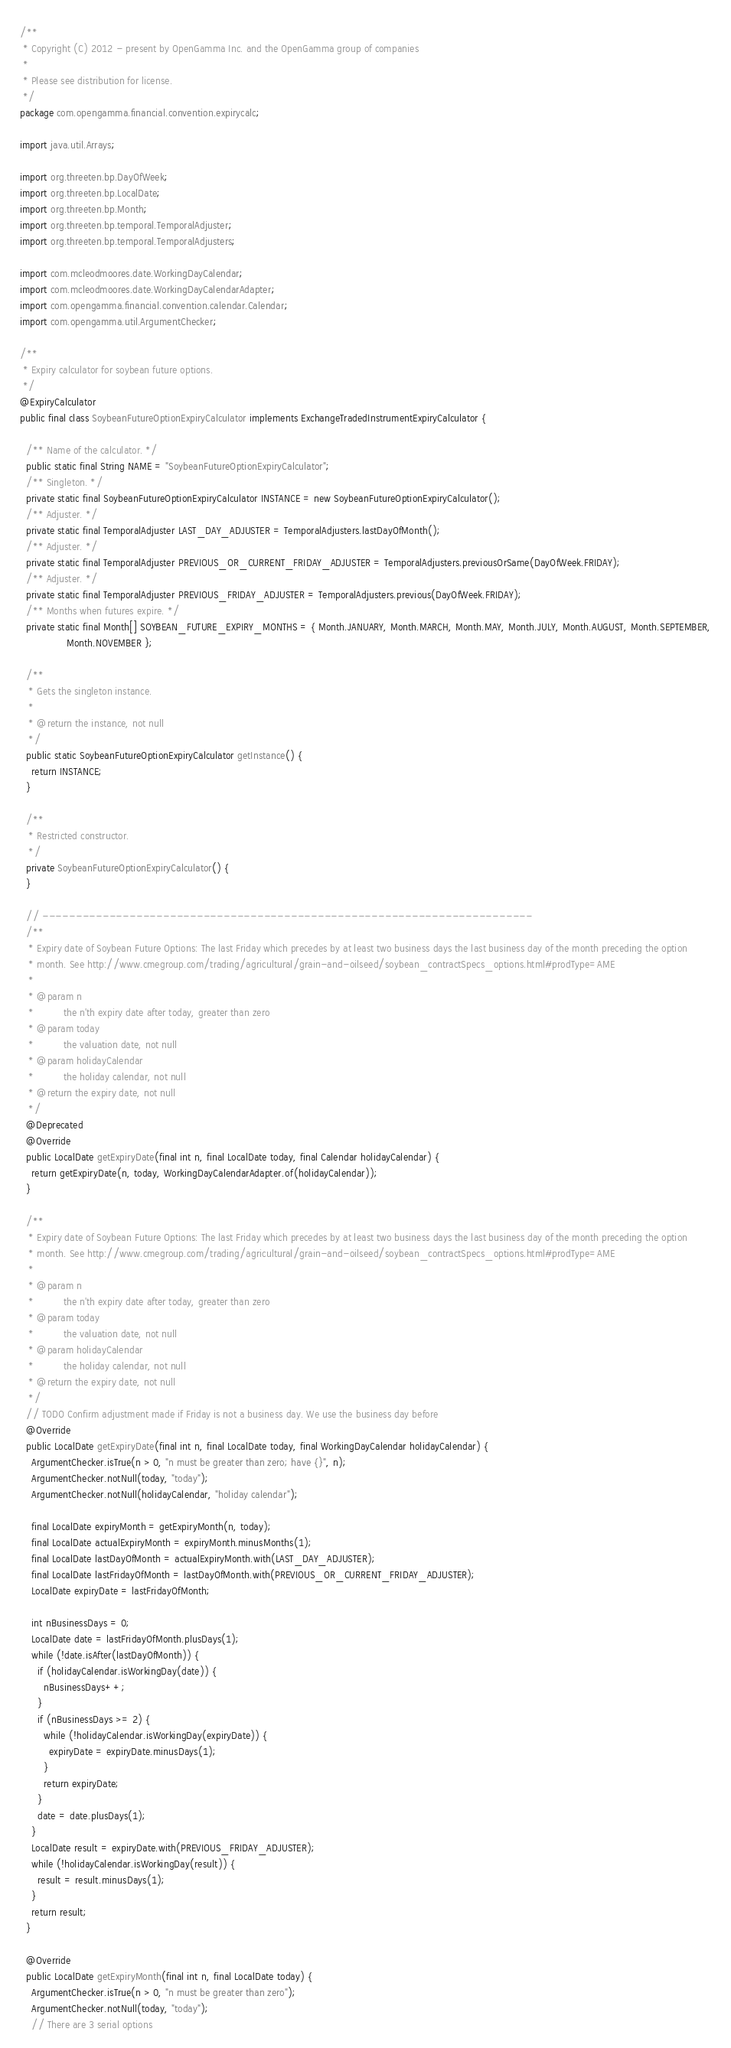<code> <loc_0><loc_0><loc_500><loc_500><_Java_>/**
 * Copyright (C) 2012 - present by OpenGamma Inc. and the OpenGamma group of companies
 *
 * Please see distribution for license.
 */
package com.opengamma.financial.convention.expirycalc;

import java.util.Arrays;

import org.threeten.bp.DayOfWeek;
import org.threeten.bp.LocalDate;
import org.threeten.bp.Month;
import org.threeten.bp.temporal.TemporalAdjuster;
import org.threeten.bp.temporal.TemporalAdjusters;

import com.mcleodmoores.date.WorkingDayCalendar;
import com.mcleodmoores.date.WorkingDayCalendarAdapter;
import com.opengamma.financial.convention.calendar.Calendar;
import com.opengamma.util.ArgumentChecker;

/**
 * Expiry calculator for soybean future options.
 */
@ExpiryCalculator
public final class SoybeanFutureOptionExpiryCalculator implements ExchangeTradedInstrumentExpiryCalculator {

  /** Name of the calculator. */
  public static final String NAME = "SoybeanFutureOptionExpiryCalculator";
  /** Singleton. */
  private static final SoybeanFutureOptionExpiryCalculator INSTANCE = new SoybeanFutureOptionExpiryCalculator();
  /** Adjuster. */
  private static final TemporalAdjuster LAST_DAY_ADJUSTER = TemporalAdjusters.lastDayOfMonth();
  /** Adjuster. */
  private static final TemporalAdjuster PREVIOUS_OR_CURRENT_FRIDAY_ADJUSTER = TemporalAdjusters.previousOrSame(DayOfWeek.FRIDAY);
  /** Adjuster. */
  private static final TemporalAdjuster PREVIOUS_FRIDAY_ADJUSTER = TemporalAdjusters.previous(DayOfWeek.FRIDAY);
  /** Months when futures expire. */
  private static final Month[] SOYBEAN_FUTURE_EXPIRY_MONTHS = { Month.JANUARY, Month.MARCH, Month.MAY, Month.JULY, Month.AUGUST, Month.SEPTEMBER,
                Month.NOVEMBER };

  /**
   * Gets the singleton instance.
   *
   * @return the instance, not null
   */
  public static SoybeanFutureOptionExpiryCalculator getInstance() {
    return INSTANCE;
  }

  /**
   * Restricted constructor.
   */
  private SoybeanFutureOptionExpiryCalculator() {
  }

  // -------------------------------------------------------------------------
  /**
   * Expiry date of Soybean Future Options: The last Friday which precedes by at least two business days the last business day of the month preceding the option
   * month. See http://www.cmegroup.com/trading/agricultural/grain-and-oilseed/soybean_contractSpecs_options.html#prodType=AME
   *
   * @param n
   *          the n'th expiry date after today, greater than zero
   * @param today
   *          the valuation date, not null
   * @param holidayCalendar
   *          the holiday calendar, not null
   * @return the expiry date, not null
   */
  @Deprecated
  @Override
  public LocalDate getExpiryDate(final int n, final LocalDate today, final Calendar holidayCalendar) {
    return getExpiryDate(n, today, WorkingDayCalendarAdapter.of(holidayCalendar));
  }

  /**
   * Expiry date of Soybean Future Options: The last Friday which precedes by at least two business days the last business day of the month preceding the option
   * month. See http://www.cmegroup.com/trading/agricultural/grain-and-oilseed/soybean_contractSpecs_options.html#prodType=AME
   *
   * @param n
   *          the n'th expiry date after today, greater than zero
   * @param today
   *          the valuation date, not null
   * @param holidayCalendar
   *          the holiday calendar, not null
   * @return the expiry date, not null
   */
  // TODO Confirm adjustment made if Friday is not a business day. We use the business day before
  @Override
  public LocalDate getExpiryDate(final int n, final LocalDate today, final WorkingDayCalendar holidayCalendar) {
    ArgumentChecker.isTrue(n > 0, "n must be greater than zero; have {}", n);
    ArgumentChecker.notNull(today, "today");
    ArgumentChecker.notNull(holidayCalendar, "holiday calendar");

    final LocalDate expiryMonth = getExpiryMonth(n, today);
    final LocalDate actualExpiryMonth = expiryMonth.minusMonths(1);
    final LocalDate lastDayOfMonth = actualExpiryMonth.with(LAST_DAY_ADJUSTER);
    final LocalDate lastFridayOfMonth = lastDayOfMonth.with(PREVIOUS_OR_CURRENT_FRIDAY_ADJUSTER);
    LocalDate expiryDate = lastFridayOfMonth;

    int nBusinessDays = 0;
    LocalDate date = lastFridayOfMonth.plusDays(1);
    while (!date.isAfter(lastDayOfMonth)) {
      if (holidayCalendar.isWorkingDay(date)) {
        nBusinessDays++;
      }
      if (nBusinessDays >= 2) {
        while (!holidayCalendar.isWorkingDay(expiryDate)) {
          expiryDate = expiryDate.minusDays(1);
        }
        return expiryDate;
      }
      date = date.plusDays(1);
    }
    LocalDate result = expiryDate.with(PREVIOUS_FRIDAY_ADJUSTER);
    while (!holidayCalendar.isWorkingDay(result)) {
      result = result.minusDays(1);
    }
    return result;
  }

  @Override
  public LocalDate getExpiryMonth(final int n, final LocalDate today) {
    ArgumentChecker.isTrue(n > 0, "n must be greater than zero");
    ArgumentChecker.notNull(today, "today");
    // There are 3 serial options</code> 